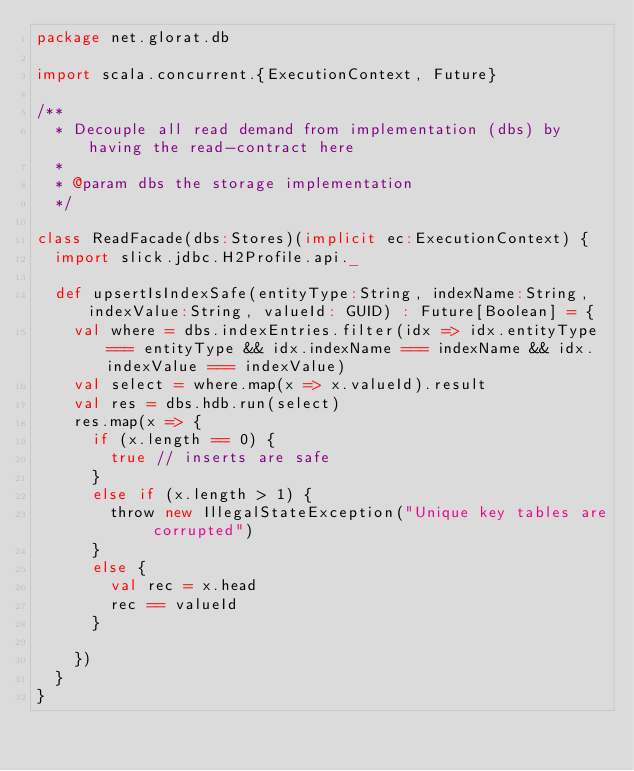<code> <loc_0><loc_0><loc_500><loc_500><_Scala_>package net.glorat.db

import scala.concurrent.{ExecutionContext, Future}

/**
  * Decouple all read demand from implementation (dbs) by having the read-contract here
  *
  * @param dbs the storage implementation
  */

class ReadFacade(dbs:Stores)(implicit ec:ExecutionContext) {
  import slick.jdbc.H2Profile.api._

  def upsertIsIndexSafe(entityType:String, indexName:String, indexValue:String, valueId: GUID) : Future[Boolean] = {
    val where = dbs.indexEntries.filter(idx => idx.entityType === entityType && idx.indexName === indexName && idx.indexValue === indexValue)
    val select = where.map(x => x.valueId).result
    val res = dbs.hdb.run(select)
    res.map(x => {
      if (x.length == 0) {
        true // inserts are safe
      }
      else if (x.length > 1) {
        throw new IllegalStateException("Unique key tables are corrupted")
      }
      else {
        val rec = x.head
        rec == valueId
      }

    })
  }
}
</code> 